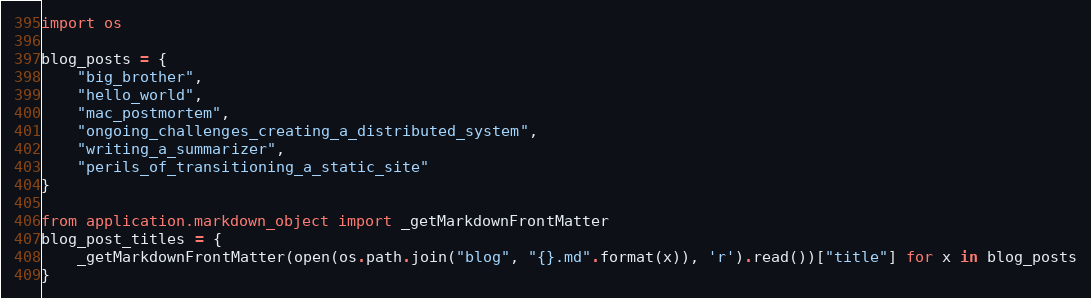<code> <loc_0><loc_0><loc_500><loc_500><_Python_>import os

blog_posts = {
    "big_brother",
    "hello_world",
    "mac_postmortem",
    "ongoing_challenges_creating_a_distributed_system",
    "writing_a_summarizer",
    "perils_of_transitioning_a_static_site"
}

from application.markdown_object import _getMarkdownFrontMatter
blog_post_titles = {
    _getMarkdownFrontMatter(open(os.path.join("blog", "{}.md".format(x)), 'r').read())["title"] for x in blog_posts
}
</code> 